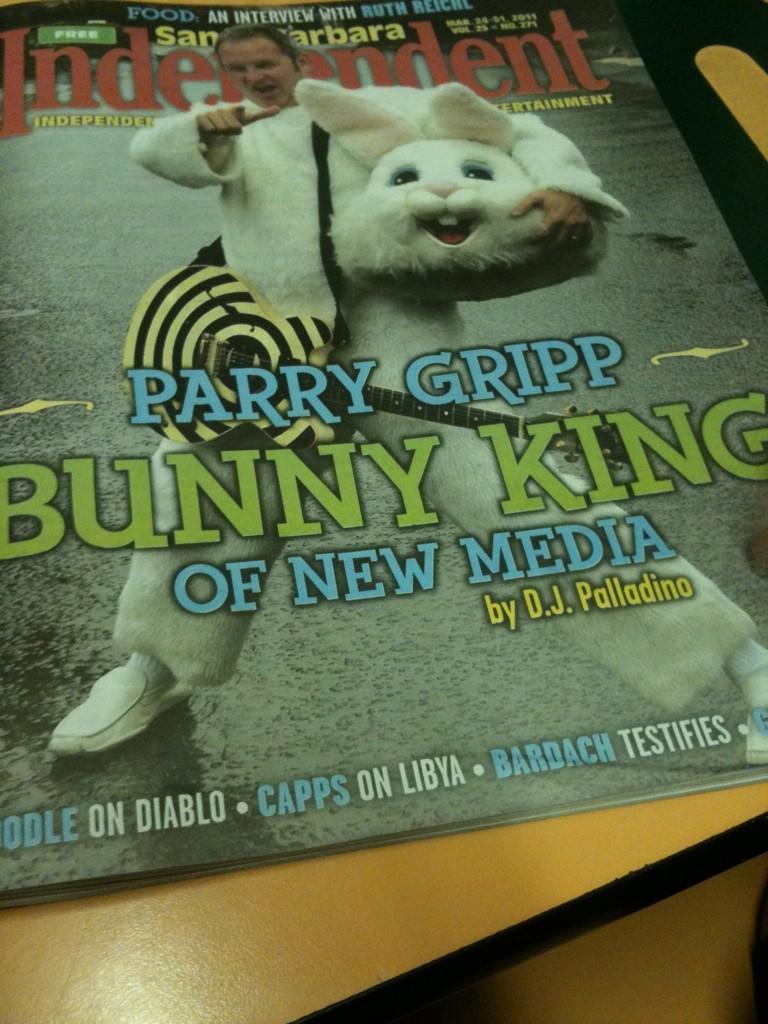What piece of furniture is present in the image? There is a table in the image. What is placed on the table? There is a poster on the table. What is depicted on the poster? The poster contains a picture of a person. Is there any text on the poster? Yes, there is writing on the poster. What type of wristwatch is the person wearing in the poster? There is no wristwatch visible in the image, as the poster only contains a picture of a person and writing. 